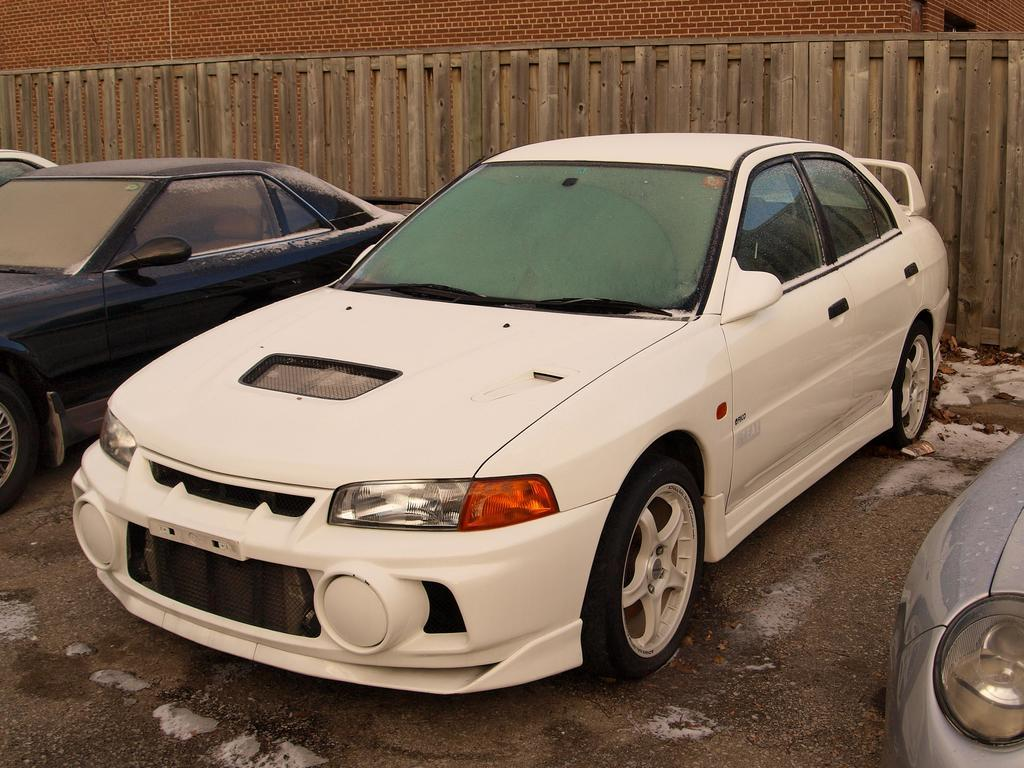What can be seen parked in the image? There are cars parked in the image. What type of structure is visible in the background of the image? There is a brick wall in the background of the image. What type of barrier is present in the image? There is fencing visible in the image. What type of space vehicle can be seen in the image? There is no space vehicle present in the image; it features parked cars, a brick wall, and fencing. How many passengers are visible in the image? There is no indication of passengers in the image, as it only shows parked cars, a brick wall, and fencing. 